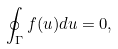Convert formula to latex. <formula><loc_0><loc_0><loc_500><loc_500>\oint _ { \Gamma } f ( u ) d u = 0 ,</formula> 